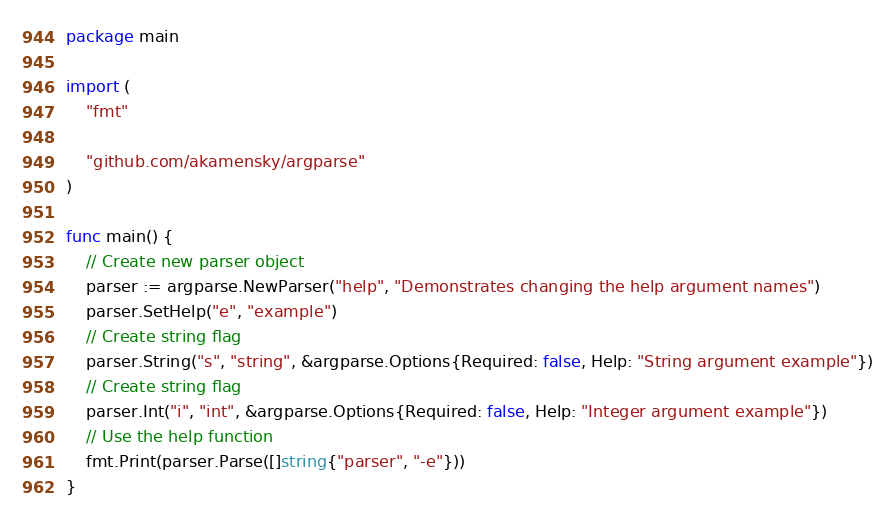Convert code to text. <code><loc_0><loc_0><loc_500><loc_500><_Go_>package main

import (
	"fmt"

	"github.com/akamensky/argparse"
)

func main() {
	// Create new parser object
	parser := argparse.NewParser("help", "Demonstrates changing the help argument names")
	parser.SetHelp("e", "example")
	// Create string flag
	parser.String("s", "string", &argparse.Options{Required: false, Help: "String argument example"})
	// Create string flag
	parser.Int("i", "int", &argparse.Options{Required: false, Help: "Integer argument example"})
	// Use the help function
	fmt.Print(parser.Parse([]string{"parser", "-e"}))
}
</code> 